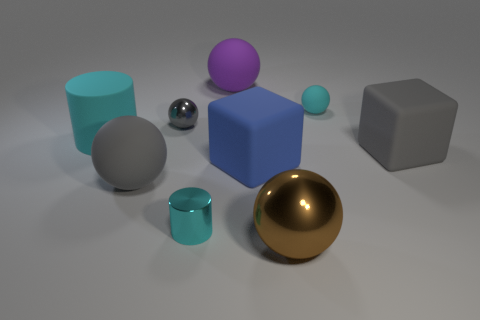Subtract all purple spheres. How many spheres are left? 4 Subtract all gray shiny spheres. How many spheres are left? 4 Subtract 1 balls. How many balls are left? 4 Subtract all red balls. Subtract all red cylinders. How many balls are left? 5 Add 1 big balls. How many objects exist? 10 Subtract all balls. How many objects are left? 4 Subtract all metallic cylinders. Subtract all rubber objects. How many objects are left? 2 Add 9 small gray spheres. How many small gray spheres are left? 10 Add 2 brown metal things. How many brown metal things exist? 3 Subtract 1 brown balls. How many objects are left? 8 